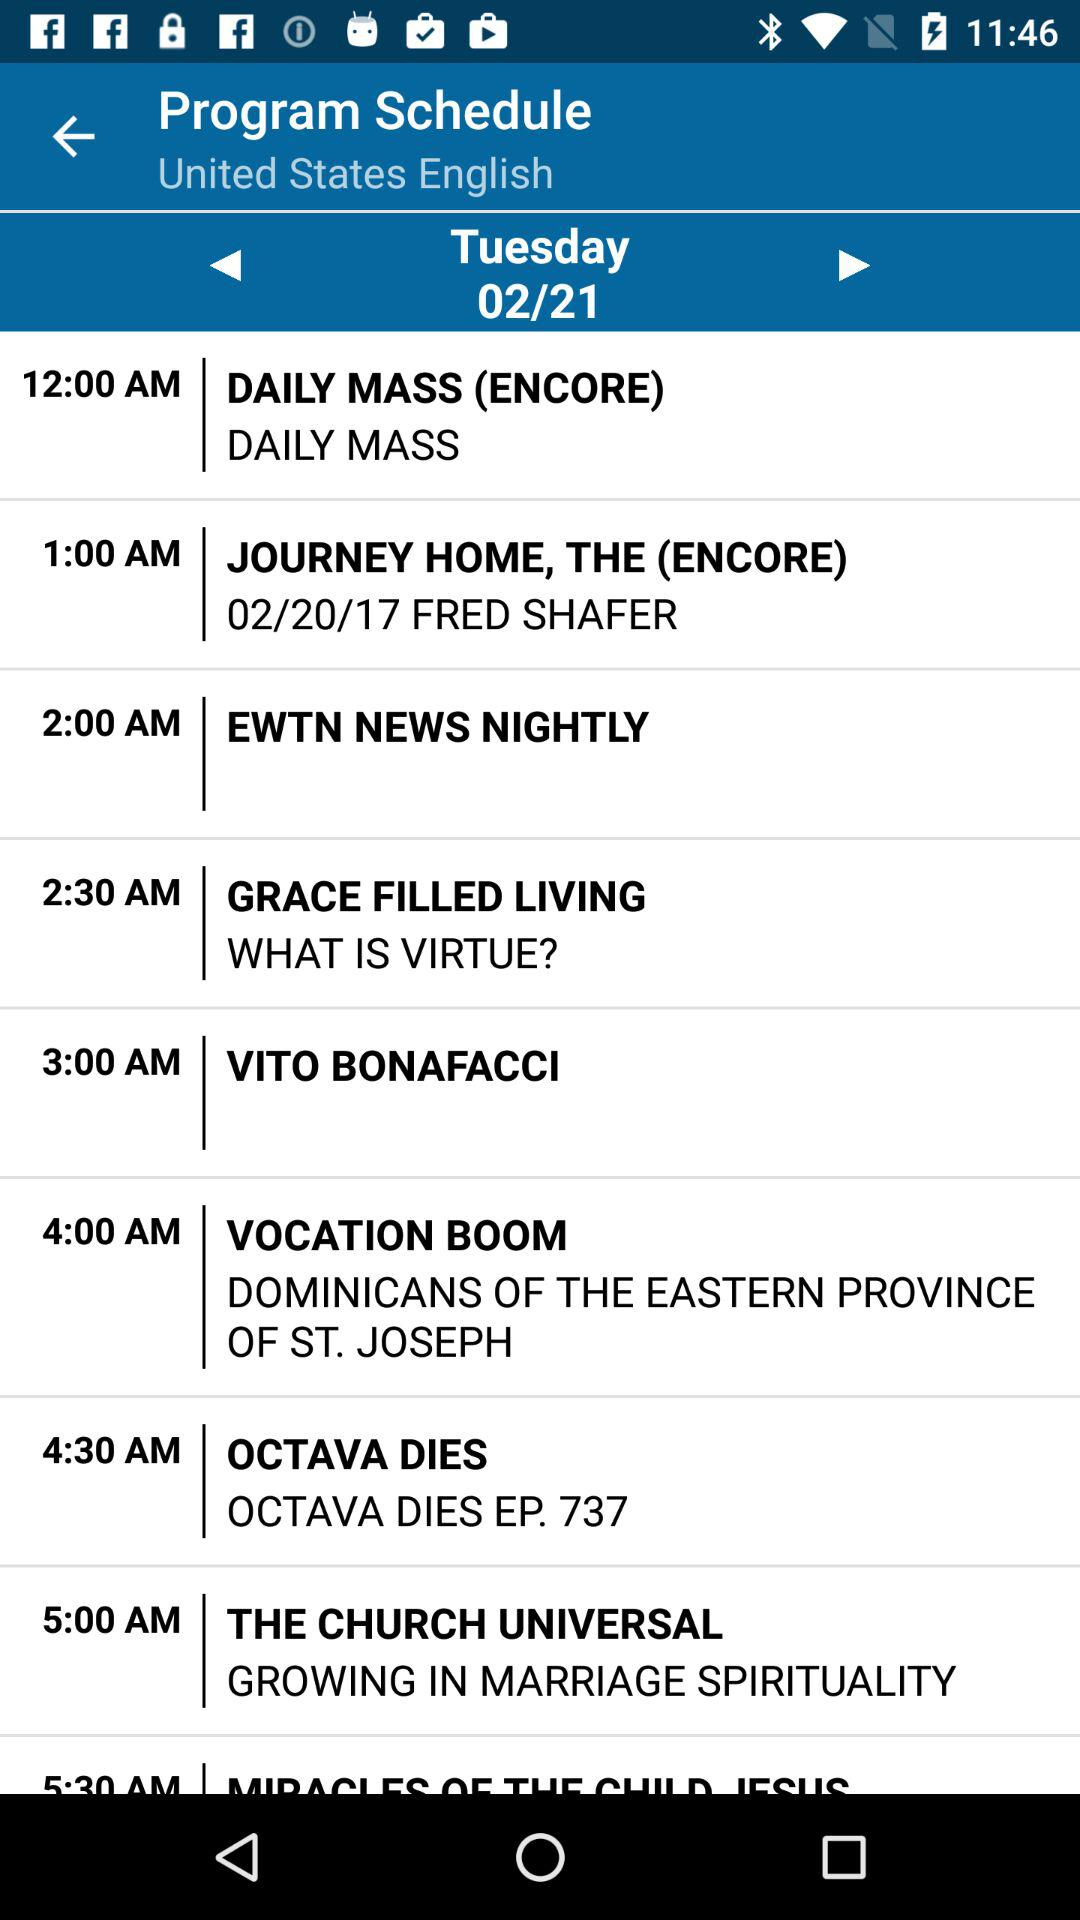What time is the "VACATION BOOM" program schedule? The "VACATION BOOM" program is scheduled for 4:00 a.m. 